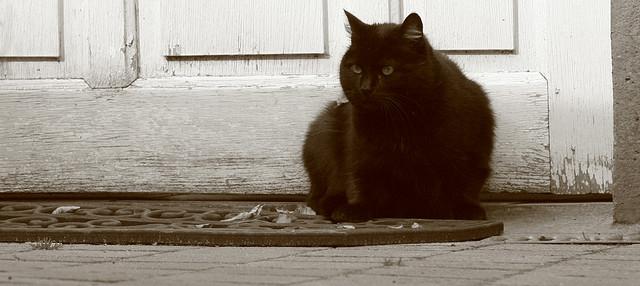Does this animal enjoy canned tuna?
Give a very brief answer. Yes. What position is the cat in?
Be succinct. Sitting. Does the cat appear to be anxious?
Answer briefly. No. 